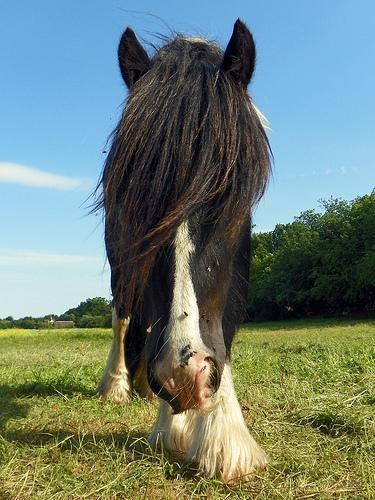How many horses are there?
Give a very brief answer. 1. 